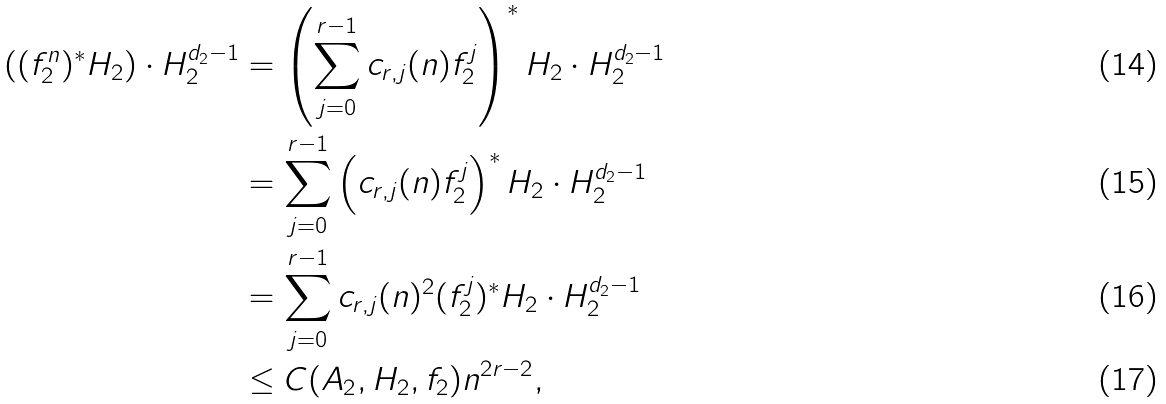Convert formula to latex. <formula><loc_0><loc_0><loc_500><loc_500>\left ( ( f _ { 2 } ^ { n } ) ^ { * } H _ { 2 } \right ) \cdot H _ { 2 } ^ { d _ { 2 } - 1 } & = \left ( \sum _ { j = 0 } ^ { r - 1 } c _ { r , j } ( n ) f _ { 2 } ^ { j } \right ) ^ { * } H _ { 2 } \cdot H _ { 2 } ^ { d _ { 2 } - 1 } \\ & = \sum _ { j = 0 } ^ { r - 1 } \left ( c _ { r , j } ( n ) f _ { 2 } ^ { j } \right ) ^ { * } H _ { 2 } \cdot H _ { 2 } ^ { d _ { 2 } - 1 } \\ & = \sum _ { j = 0 } ^ { r - 1 } c _ { r , j } ( n ) ^ { 2 } ( f _ { 2 } ^ { j } ) ^ { * } H _ { 2 } \cdot H _ { 2 } ^ { d _ { 2 } - 1 } \\ & \leq C ( A _ { 2 } , H _ { 2 } , f _ { 2 } ) n ^ { 2 r - 2 } ,</formula> 